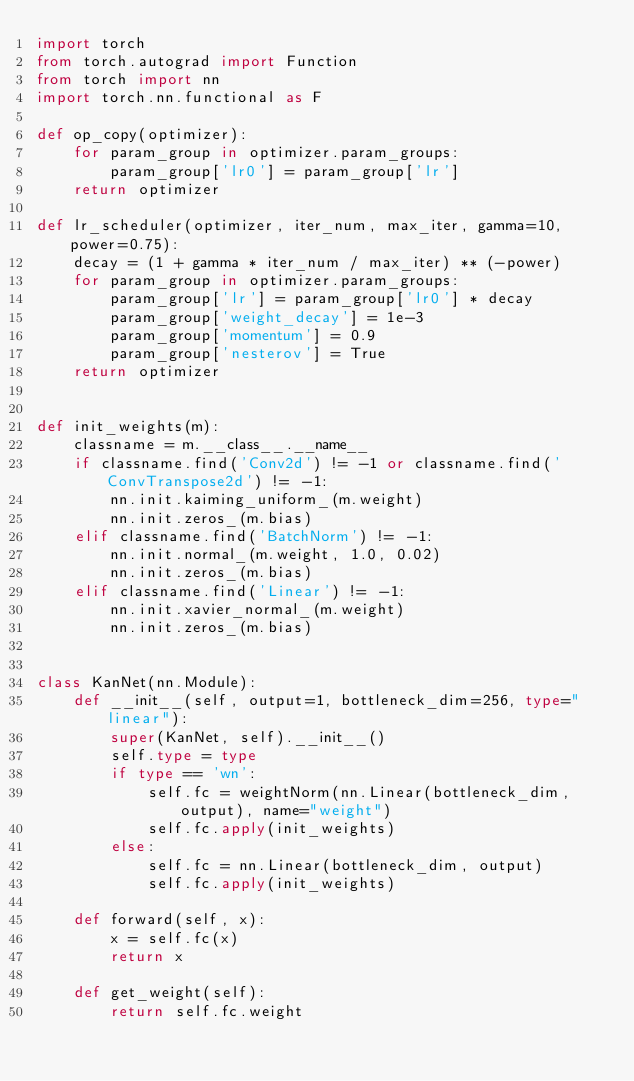Convert code to text. <code><loc_0><loc_0><loc_500><loc_500><_Python_>import torch
from torch.autograd import Function
from torch import nn
import torch.nn.functional as F

def op_copy(optimizer):
    for param_group in optimizer.param_groups:
        param_group['lr0'] = param_group['lr']
    return optimizer

def lr_scheduler(optimizer, iter_num, max_iter, gamma=10, power=0.75):
    decay = (1 + gamma * iter_num / max_iter) ** (-power)
    for param_group in optimizer.param_groups:
        param_group['lr'] = param_group['lr0'] * decay
        param_group['weight_decay'] = 1e-3
        param_group['momentum'] = 0.9
        param_group['nesterov'] = True
    return optimizer
    

def init_weights(m):
    classname = m.__class__.__name__
    if classname.find('Conv2d') != -1 or classname.find('ConvTranspose2d') != -1:
        nn.init.kaiming_uniform_(m.weight)
        nn.init.zeros_(m.bias)
    elif classname.find('BatchNorm') != -1:
        nn.init.normal_(m.weight, 1.0, 0.02)
        nn.init.zeros_(m.bias)
    elif classname.find('Linear') != -1:
        nn.init.xavier_normal_(m.weight)
        nn.init.zeros_(m.bias)


class KanNet(nn.Module):
    def __init__(self, output=1, bottleneck_dim=256, type="linear"):
        super(KanNet, self).__init__()
        self.type = type
        if type == 'wn':
            self.fc = weightNorm(nn.Linear(bottleneck_dim, output), name="weight")
            self.fc.apply(init_weights)
        else:
            self.fc = nn.Linear(bottleneck_dim, output)
            self.fc.apply(init_weights)

    def forward(self, x):
        x = self.fc(x)
        return x

    def get_weight(self):
        return self.fc.weight
</code> 